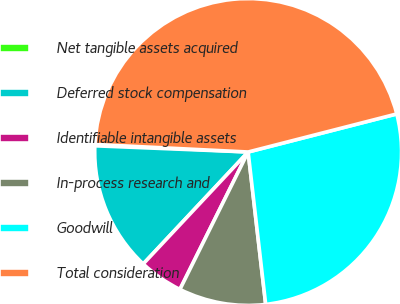Convert chart to OTSL. <chart><loc_0><loc_0><loc_500><loc_500><pie_chart><fcel>Net tangible assets acquired<fcel>Deferred stock compensation<fcel>Identifiable intangible assets<fcel>In-process research and<fcel>Goodwill<fcel>Total consideration<nl><fcel>0.14%<fcel>13.66%<fcel>4.65%<fcel>9.16%<fcel>27.17%<fcel>45.23%<nl></chart> 